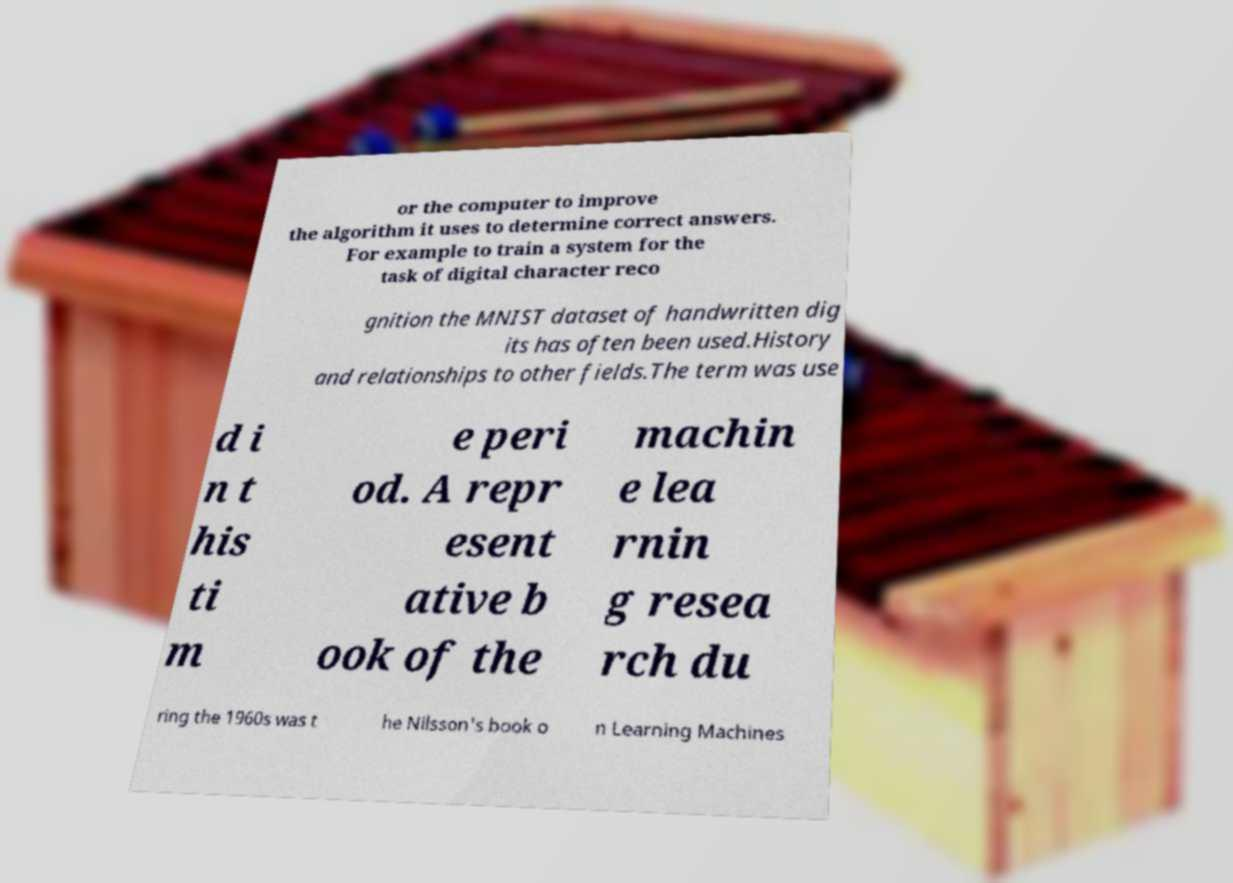What messages or text are displayed in this image? I need them in a readable, typed format. or the computer to improve the algorithm it uses to determine correct answers. For example to train a system for the task of digital character reco gnition the MNIST dataset of handwritten dig its has often been used.History and relationships to other fields.The term was use d i n t his ti m e peri od. A repr esent ative b ook of the machin e lea rnin g resea rch du ring the 1960s was t he Nilsson's book o n Learning Machines 